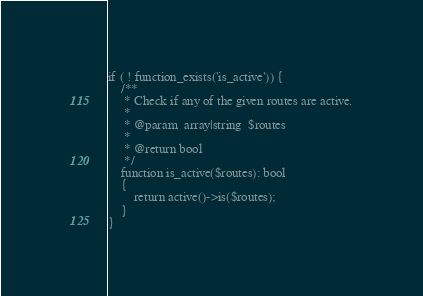Convert code to text. <code><loc_0><loc_0><loc_500><loc_500><_PHP_>if ( ! function_exists('is_active')) {
    /**
     * Check if any of the given routes are active.
     *
     * @param  array|string  $routes
     *
     * @return bool
     */
    function is_active($routes): bool
    {
        return active()->is($routes);
    }
}
</code> 